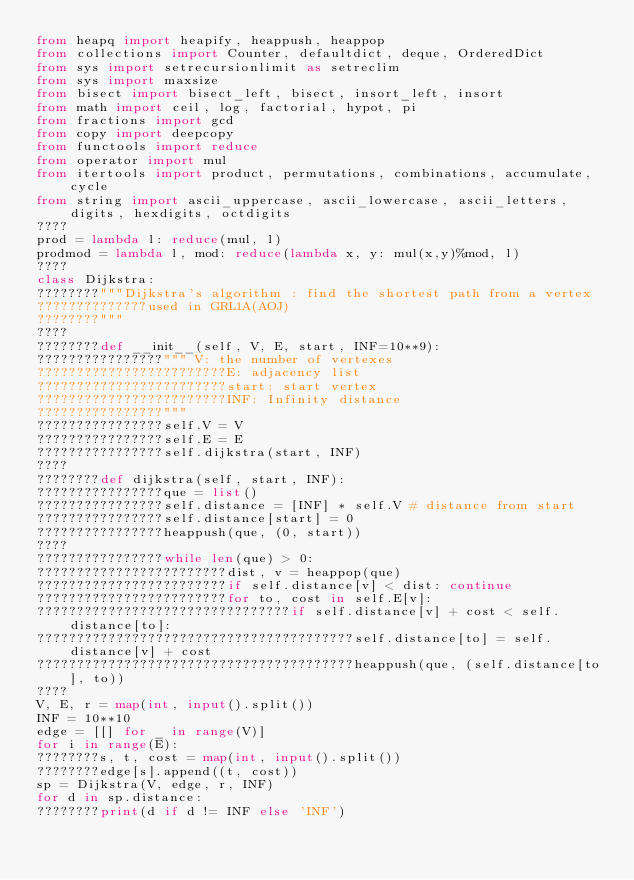Convert code to text. <code><loc_0><loc_0><loc_500><loc_500><_Python_>from heapq import heapify, heappush, heappop
from collections import Counter, defaultdict, deque, OrderedDict
from sys import setrecursionlimit as setreclim
from sys import maxsize
from bisect import bisect_left, bisect, insort_left, insort
from math import ceil, log, factorial, hypot, pi
from fractions import gcd
from copy import deepcopy
from functools import reduce
from operator import mul
from itertools import product, permutations, combinations, accumulate, cycle
from string import ascii_uppercase, ascii_lowercase, ascii_letters, digits, hexdigits, octdigits
????
prod = lambda l: reduce(mul, l)
prodmod = lambda l, mod: reduce(lambda x, y: mul(x,y)%mod, l)
????
class Dijkstra:
????????"""Dijkstra's algorithm : find the shortest path from a vertex
??????????????used in GRL1A(AOJ)
????????"""
????
????????def __init__(self, V, E, start, INF=10**9):
????????????????""" V: the number of vertexes
????????????????????????E: adjacency list
????????????????????????start: start vertex
????????????????????????INF: Infinity distance
????????????????"""
????????????????self.V = V
????????????????self.E = E
????????????????self.dijkstra(start, INF)
????
????????def dijkstra(self, start, INF):
????????????????que = list()
????????????????self.distance = [INF] * self.V # distance from start
????????????????self.distance[start] = 0
????????????????heappush(que, (0, start))
????
????????????????while len(que) > 0:
????????????????????????dist, v = heappop(que)
????????????????????????if self.distance[v] < dist: continue
????????????????????????for to, cost in self.E[v]:
????????????????????????????????if self.distance[v] + cost < self.distance[to]:
????????????????????????????????????????self.distance[to] = self.distance[v] + cost
????????????????????????????????????????heappush(que, (self.distance[to], to))
????
V, E, r = map(int, input().split())
INF = 10**10
edge = [[] for _ in range(V)]
for i in range(E):
????????s, t, cost = map(int, input().split())
????????edge[s].append((t, cost))
sp = Dijkstra(V, edge, r, INF)
for d in sp.distance:
????????print(d if d != INF else 'INF')</code> 